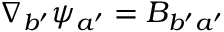Convert formula to latex. <formula><loc_0><loc_0><loc_500><loc_500>\nabla _ { b ^ { \prime } } \psi _ { a ^ { \prime } } = B _ { b ^ { \prime } a ^ { \prime } }</formula> 